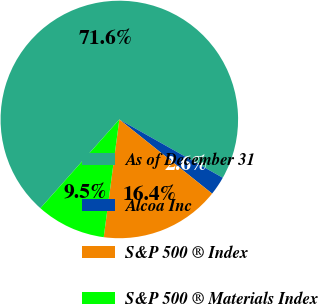<chart> <loc_0><loc_0><loc_500><loc_500><pie_chart><fcel>As of December 31<fcel>Alcoa Inc<fcel>S&P 500 ® Index<fcel>S&P 500 ® Materials Index<nl><fcel>71.6%<fcel>2.56%<fcel>16.37%<fcel>9.47%<nl></chart> 